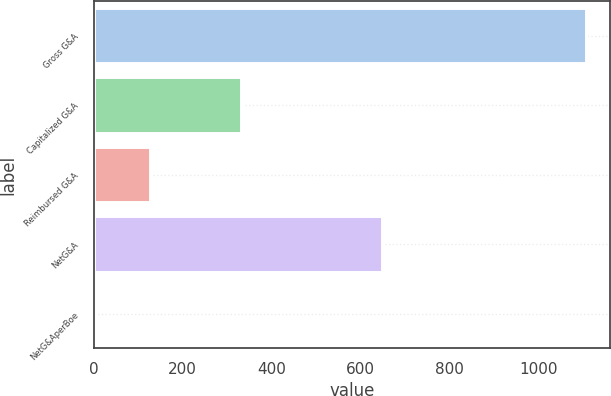Convert chart. <chart><loc_0><loc_0><loc_500><loc_500><bar_chart><fcel>Gross G&A<fcel>Capitalized G&A<fcel>Reimbursed G&A<fcel>NetG&A<fcel>NetG&AperBoe<nl><fcel>1107<fcel>332<fcel>127<fcel>648<fcel>2.78<nl></chart> 